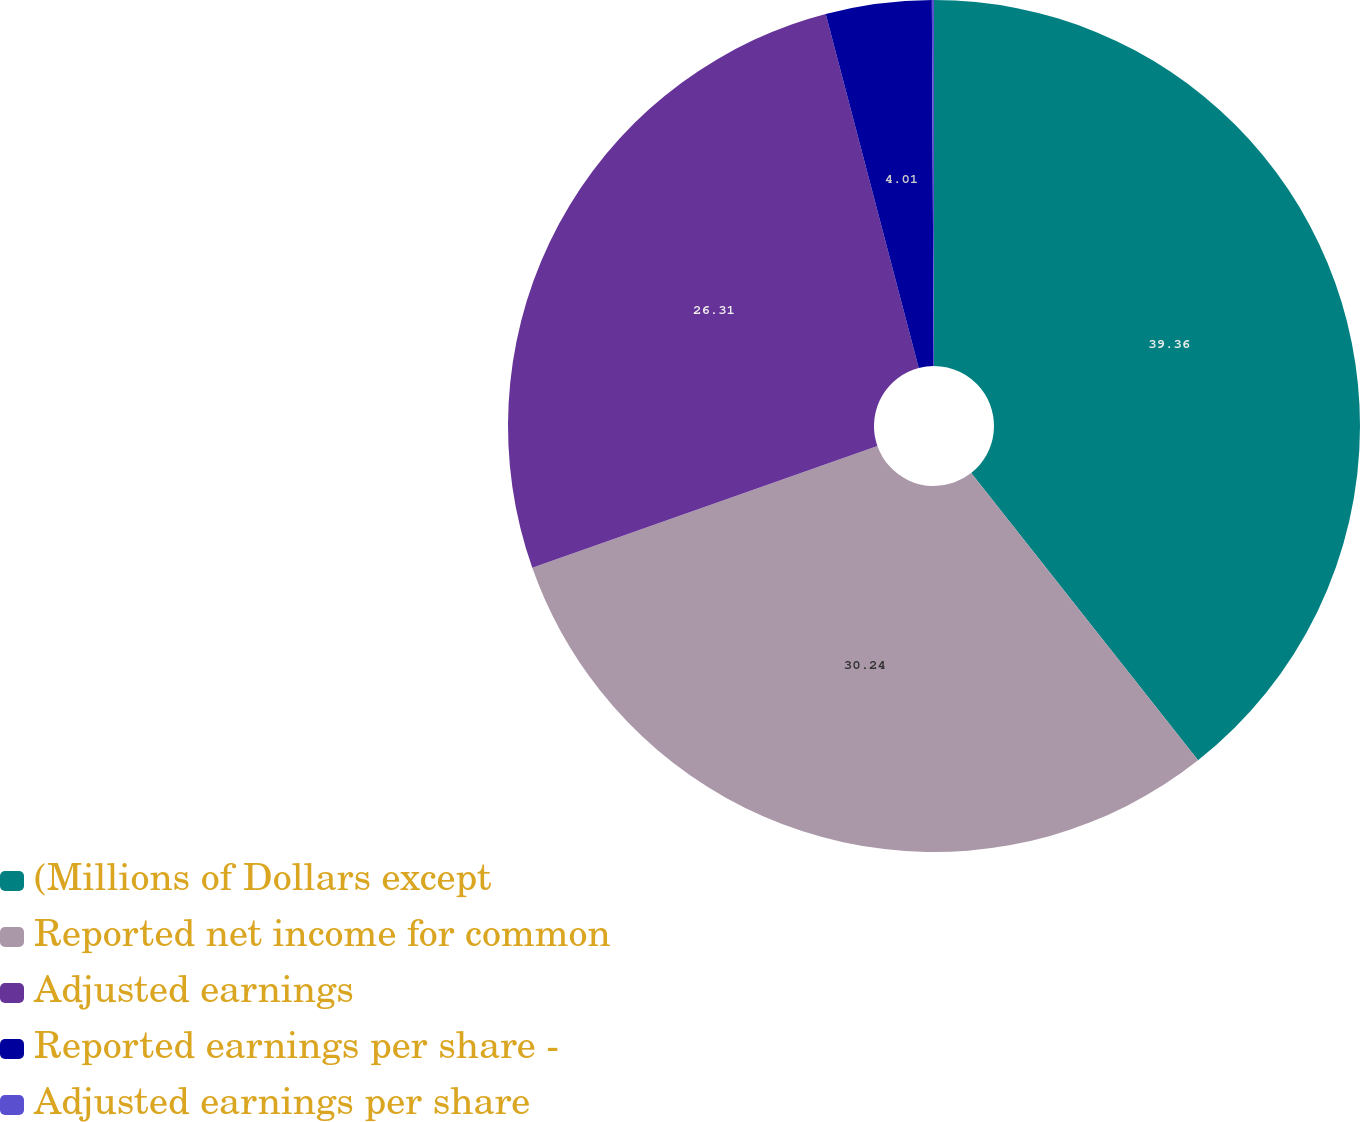Convert chart. <chart><loc_0><loc_0><loc_500><loc_500><pie_chart><fcel>(Millions of Dollars except<fcel>Reported net income for common<fcel>Adjusted earnings<fcel>Reported earnings per share -<fcel>Adjusted earnings per share<nl><fcel>39.36%<fcel>30.24%<fcel>26.31%<fcel>4.01%<fcel>0.08%<nl></chart> 